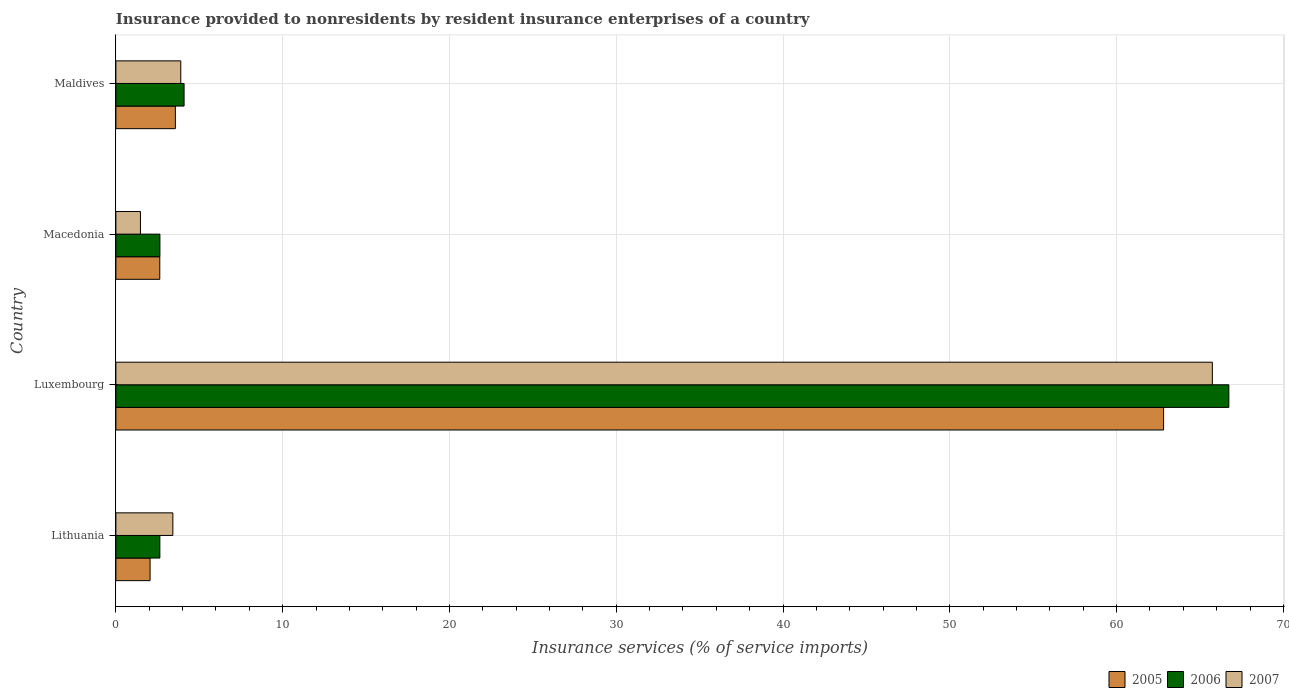How many different coloured bars are there?
Ensure brevity in your answer.  3. Are the number of bars on each tick of the Y-axis equal?
Offer a very short reply. Yes. How many bars are there on the 3rd tick from the top?
Keep it short and to the point. 3. How many bars are there on the 4th tick from the bottom?
Provide a succinct answer. 3. What is the label of the 4th group of bars from the top?
Offer a very short reply. Lithuania. What is the insurance provided to nonresidents in 2007 in Luxembourg?
Make the answer very short. 65.74. Across all countries, what is the maximum insurance provided to nonresidents in 2007?
Offer a very short reply. 65.74. Across all countries, what is the minimum insurance provided to nonresidents in 2006?
Ensure brevity in your answer.  2.64. In which country was the insurance provided to nonresidents in 2005 maximum?
Your response must be concise. Luxembourg. In which country was the insurance provided to nonresidents in 2007 minimum?
Your answer should be very brief. Macedonia. What is the total insurance provided to nonresidents in 2007 in the graph?
Keep it short and to the point. 74.52. What is the difference between the insurance provided to nonresidents in 2005 in Lithuania and that in Macedonia?
Your answer should be very brief. -0.58. What is the difference between the insurance provided to nonresidents in 2005 in Luxembourg and the insurance provided to nonresidents in 2006 in Macedonia?
Provide a succinct answer. 60.18. What is the average insurance provided to nonresidents in 2006 per country?
Give a very brief answer. 19.02. What is the difference between the insurance provided to nonresidents in 2006 and insurance provided to nonresidents in 2005 in Luxembourg?
Offer a terse response. 3.91. In how many countries, is the insurance provided to nonresidents in 2006 greater than 48 %?
Your response must be concise. 1. What is the ratio of the insurance provided to nonresidents in 2007 in Lithuania to that in Maldives?
Your response must be concise. 0.88. Is the insurance provided to nonresidents in 2006 in Lithuania less than that in Macedonia?
Offer a very short reply. Yes. What is the difference between the highest and the second highest insurance provided to nonresidents in 2007?
Provide a succinct answer. 61.85. What is the difference between the highest and the lowest insurance provided to nonresidents in 2007?
Give a very brief answer. 64.27. In how many countries, is the insurance provided to nonresidents in 2006 greater than the average insurance provided to nonresidents in 2006 taken over all countries?
Provide a succinct answer. 1. Is the sum of the insurance provided to nonresidents in 2006 in Luxembourg and Macedonia greater than the maximum insurance provided to nonresidents in 2005 across all countries?
Your answer should be very brief. Yes. Is it the case that in every country, the sum of the insurance provided to nonresidents in 2006 and insurance provided to nonresidents in 2007 is greater than the insurance provided to nonresidents in 2005?
Your response must be concise. Yes. Are all the bars in the graph horizontal?
Your answer should be compact. Yes. How many countries are there in the graph?
Provide a short and direct response. 4. Are the values on the major ticks of X-axis written in scientific E-notation?
Your response must be concise. No. Where does the legend appear in the graph?
Ensure brevity in your answer.  Bottom right. How are the legend labels stacked?
Your response must be concise. Horizontal. What is the title of the graph?
Offer a terse response. Insurance provided to nonresidents by resident insurance enterprises of a country. Does "1991" appear as one of the legend labels in the graph?
Keep it short and to the point. No. What is the label or title of the X-axis?
Offer a terse response. Insurance services (% of service imports). What is the Insurance services (% of service imports) in 2005 in Lithuania?
Your answer should be compact. 2.05. What is the Insurance services (% of service imports) of 2006 in Lithuania?
Ensure brevity in your answer.  2.64. What is the Insurance services (% of service imports) of 2007 in Lithuania?
Your answer should be very brief. 3.42. What is the Insurance services (% of service imports) of 2005 in Luxembourg?
Keep it short and to the point. 62.82. What is the Insurance services (% of service imports) of 2006 in Luxembourg?
Keep it short and to the point. 66.73. What is the Insurance services (% of service imports) of 2007 in Luxembourg?
Offer a terse response. 65.74. What is the Insurance services (% of service imports) of 2005 in Macedonia?
Give a very brief answer. 2.63. What is the Insurance services (% of service imports) of 2006 in Macedonia?
Your answer should be very brief. 2.64. What is the Insurance services (% of service imports) of 2007 in Macedonia?
Ensure brevity in your answer.  1.47. What is the Insurance services (% of service imports) in 2005 in Maldives?
Ensure brevity in your answer.  3.57. What is the Insurance services (% of service imports) in 2006 in Maldives?
Your answer should be very brief. 4.09. What is the Insurance services (% of service imports) of 2007 in Maldives?
Your answer should be very brief. 3.89. Across all countries, what is the maximum Insurance services (% of service imports) of 2005?
Ensure brevity in your answer.  62.82. Across all countries, what is the maximum Insurance services (% of service imports) of 2006?
Offer a terse response. 66.73. Across all countries, what is the maximum Insurance services (% of service imports) of 2007?
Make the answer very short. 65.74. Across all countries, what is the minimum Insurance services (% of service imports) of 2005?
Make the answer very short. 2.05. Across all countries, what is the minimum Insurance services (% of service imports) in 2006?
Your answer should be compact. 2.64. Across all countries, what is the minimum Insurance services (% of service imports) in 2007?
Make the answer very short. 1.47. What is the total Insurance services (% of service imports) in 2005 in the graph?
Your response must be concise. 71.07. What is the total Insurance services (% of service imports) of 2006 in the graph?
Keep it short and to the point. 76.09. What is the total Insurance services (% of service imports) in 2007 in the graph?
Offer a very short reply. 74.52. What is the difference between the Insurance services (% of service imports) in 2005 in Lithuania and that in Luxembourg?
Make the answer very short. -60.77. What is the difference between the Insurance services (% of service imports) in 2006 in Lithuania and that in Luxembourg?
Make the answer very short. -64.09. What is the difference between the Insurance services (% of service imports) of 2007 in Lithuania and that in Luxembourg?
Your response must be concise. -62.33. What is the difference between the Insurance services (% of service imports) of 2005 in Lithuania and that in Macedonia?
Keep it short and to the point. -0.58. What is the difference between the Insurance services (% of service imports) of 2006 in Lithuania and that in Macedonia?
Give a very brief answer. -0. What is the difference between the Insurance services (% of service imports) in 2007 in Lithuania and that in Macedonia?
Keep it short and to the point. 1.94. What is the difference between the Insurance services (% of service imports) in 2005 in Lithuania and that in Maldives?
Offer a very short reply. -1.52. What is the difference between the Insurance services (% of service imports) in 2006 in Lithuania and that in Maldives?
Make the answer very short. -1.45. What is the difference between the Insurance services (% of service imports) in 2007 in Lithuania and that in Maldives?
Your answer should be very brief. -0.48. What is the difference between the Insurance services (% of service imports) in 2005 in Luxembourg and that in Macedonia?
Your answer should be compact. 60.19. What is the difference between the Insurance services (% of service imports) of 2006 in Luxembourg and that in Macedonia?
Your answer should be compact. 64.09. What is the difference between the Insurance services (% of service imports) in 2007 in Luxembourg and that in Macedonia?
Provide a short and direct response. 64.27. What is the difference between the Insurance services (% of service imports) of 2005 in Luxembourg and that in Maldives?
Provide a short and direct response. 59.25. What is the difference between the Insurance services (% of service imports) in 2006 in Luxembourg and that in Maldives?
Your answer should be compact. 62.64. What is the difference between the Insurance services (% of service imports) of 2007 in Luxembourg and that in Maldives?
Offer a terse response. 61.85. What is the difference between the Insurance services (% of service imports) in 2005 in Macedonia and that in Maldives?
Keep it short and to the point. -0.93. What is the difference between the Insurance services (% of service imports) in 2006 in Macedonia and that in Maldives?
Your response must be concise. -1.45. What is the difference between the Insurance services (% of service imports) of 2007 in Macedonia and that in Maldives?
Make the answer very short. -2.42. What is the difference between the Insurance services (% of service imports) of 2005 in Lithuania and the Insurance services (% of service imports) of 2006 in Luxembourg?
Offer a terse response. -64.68. What is the difference between the Insurance services (% of service imports) in 2005 in Lithuania and the Insurance services (% of service imports) in 2007 in Luxembourg?
Give a very brief answer. -63.69. What is the difference between the Insurance services (% of service imports) in 2006 in Lithuania and the Insurance services (% of service imports) in 2007 in Luxembourg?
Offer a very short reply. -63.1. What is the difference between the Insurance services (% of service imports) in 2005 in Lithuania and the Insurance services (% of service imports) in 2006 in Macedonia?
Offer a very short reply. -0.59. What is the difference between the Insurance services (% of service imports) in 2005 in Lithuania and the Insurance services (% of service imports) in 2007 in Macedonia?
Your answer should be very brief. 0.58. What is the difference between the Insurance services (% of service imports) of 2006 in Lithuania and the Insurance services (% of service imports) of 2007 in Macedonia?
Ensure brevity in your answer.  1.16. What is the difference between the Insurance services (% of service imports) of 2005 in Lithuania and the Insurance services (% of service imports) of 2006 in Maldives?
Your answer should be very brief. -2.04. What is the difference between the Insurance services (% of service imports) in 2005 in Lithuania and the Insurance services (% of service imports) in 2007 in Maldives?
Give a very brief answer. -1.84. What is the difference between the Insurance services (% of service imports) in 2006 in Lithuania and the Insurance services (% of service imports) in 2007 in Maldives?
Give a very brief answer. -1.25. What is the difference between the Insurance services (% of service imports) of 2005 in Luxembourg and the Insurance services (% of service imports) of 2006 in Macedonia?
Offer a terse response. 60.18. What is the difference between the Insurance services (% of service imports) of 2005 in Luxembourg and the Insurance services (% of service imports) of 2007 in Macedonia?
Make the answer very short. 61.35. What is the difference between the Insurance services (% of service imports) in 2006 in Luxembourg and the Insurance services (% of service imports) in 2007 in Macedonia?
Offer a very short reply. 65.26. What is the difference between the Insurance services (% of service imports) of 2005 in Luxembourg and the Insurance services (% of service imports) of 2006 in Maldives?
Your answer should be very brief. 58.73. What is the difference between the Insurance services (% of service imports) in 2005 in Luxembourg and the Insurance services (% of service imports) in 2007 in Maldives?
Keep it short and to the point. 58.93. What is the difference between the Insurance services (% of service imports) in 2006 in Luxembourg and the Insurance services (% of service imports) in 2007 in Maldives?
Offer a terse response. 62.84. What is the difference between the Insurance services (% of service imports) in 2005 in Macedonia and the Insurance services (% of service imports) in 2006 in Maldives?
Your answer should be very brief. -1.46. What is the difference between the Insurance services (% of service imports) of 2005 in Macedonia and the Insurance services (% of service imports) of 2007 in Maldives?
Ensure brevity in your answer.  -1.26. What is the difference between the Insurance services (% of service imports) in 2006 in Macedonia and the Insurance services (% of service imports) in 2007 in Maldives?
Offer a very short reply. -1.25. What is the average Insurance services (% of service imports) in 2005 per country?
Your response must be concise. 17.77. What is the average Insurance services (% of service imports) of 2006 per country?
Your answer should be very brief. 19.02. What is the average Insurance services (% of service imports) in 2007 per country?
Your response must be concise. 18.63. What is the difference between the Insurance services (% of service imports) in 2005 and Insurance services (% of service imports) in 2006 in Lithuania?
Provide a short and direct response. -0.59. What is the difference between the Insurance services (% of service imports) of 2005 and Insurance services (% of service imports) of 2007 in Lithuania?
Provide a succinct answer. -1.37. What is the difference between the Insurance services (% of service imports) of 2006 and Insurance services (% of service imports) of 2007 in Lithuania?
Give a very brief answer. -0.78. What is the difference between the Insurance services (% of service imports) of 2005 and Insurance services (% of service imports) of 2006 in Luxembourg?
Your response must be concise. -3.91. What is the difference between the Insurance services (% of service imports) of 2005 and Insurance services (% of service imports) of 2007 in Luxembourg?
Your answer should be compact. -2.92. What is the difference between the Insurance services (% of service imports) in 2006 and Insurance services (% of service imports) in 2007 in Luxembourg?
Offer a very short reply. 0.99. What is the difference between the Insurance services (% of service imports) of 2005 and Insurance services (% of service imports) of 2006 in Macedonia?
Offer a very short reply. -0.01. What is the difference between the Insurance services (% of service imports) of 2005 and Insurance services (% of service imports) of 2007 in Macedonia?
Offer a terse response. 1.16. What is the difference between the Insurance services (% of service imports) of 2006 and Insurance services (% of service imports) of 2007 in Macedonia?
Keep it short and to the point. 1.17. What is the difference between the Insurance services (% of service imports) of 2005 and Insurance services (% of service imports) of 2006 in Maldives?
Your response must be concise. -0.52. What is the difference between the Insurance services (% of service imports) in 2005 and Insurance services (% of service imports) in 2007 in Maldives?
Make the answer very short. -0.33. What is the difference between the Insurance services (% of service imports) in 2006 and Insurance services (% of service imports) in 2007 in Maldives?
Offer a terse response. 0.2. What is the ratio of the Insurance services (% of service imports) of 2005 in Lithuania to that in Luxembourg?
Offer a terse response. 0.03. What is the ratio of the Insurance services (% of service imports) in 2006 in Lithuania to that in Luxembourg?
Keep it short and to the point. 0.04. What is the ratio of the Insurance services (% of service imports) in 2007 in Lithuania to that in Luxembourg?
Your answer should be very brief. 0.05. What is the ratio of the Insurance services (% of service imports) in 2005 in Lithuania to that in Macedonia?
Your answer should be very brief. 0.78. What is the ratio of the Insurance services (% of service imports) of 2006 in Lithuania to that in Macedonia?
Your answer should be compact. 1. What is the ratio of the Insurance services (% of service imports) of 2007 in Lithuania to that in Macedonia?
Keep it short and to the point. 2.32. What is the ratio of the Insurance services (% of service imports) of 2005 in Lithuania to that in Maldives?
Offer a terse response. 0.57. What is the ratio of the Insurance services (% of service imports) of 2006 in Lithuania to that in Maldives?
Give a very brief answer. 0.64. What is the ratio of the Insurance services (% of service imports) of 2007 in Lithuania to that in Maldives?
Offer a terse response. 0.88. What is the ratio of the Insurance services (% of service imports) in 2005 in Luxembourg to that in Macedonia?
Give a very brief answer. 23.87. What is the ratio of the Insurance services (% of service imports) in 2006 in Luxembourg to that in Macedonia?
Your answer should be very brief. 25.28. What is the ratio of the Insurance services (% of service imports) in 2007 in Luxembourg to that in Macedonia?
Make the answer very short. 44.64. What is the ratio of the Insurance services (% of service imports) of 2005 in Luxembourg to that in Maldives?
Provide a short and direct response. 17.62. What is the ratio of the Insurance services (% of service imports) of 2006 in Luxembourg to that in Maldives?
Offer a very short reply. 16.32. What is the ratio of the Insurance services (% of service imports) in 2007 in Luxembourg to that in Maldives?
Your answer should be very brief. 16.9. What is the ratio of the Insurance services (% of service imports) of 2005 in Macedonia to that in Maldives?
Offer a terse response. 0.74. What is the ratio of the Insurance services (% of service imports) in 2006 in Macedonia to that in Maldives?
Keep it short and to the point. 0.65. What is the ratio of the Insurance services (% of service imports) of 2007 in Macedonia to that in Maldives?
Offer a very short reply. 0.38. What is the difference between the highest and the second highest Insurance services (% of service imports) in 2005?
Provide a succinct answer. 59.25. What is the difference between the highest and the second highest Insurance services (% of service imports) of 2006?
Offer a terse response. 62.64. What is the difference between the highest and the second highest Insurance services (% of service imports) in 2007?
Provide a succinct answer. 61.85. What is the difference between the highest and the lowest Insurance services (% of service imports) in 2005?
Offer a very short reply. 60.77. What is the difference between the highest and the lowest Insurance services (% of service imports) of 2006?
Provide a succinct answer. 64.09. What is the difference between the highest and the lowest Insurance services (% of service imports) in 2007?
Offer a terse response. 64.27. 